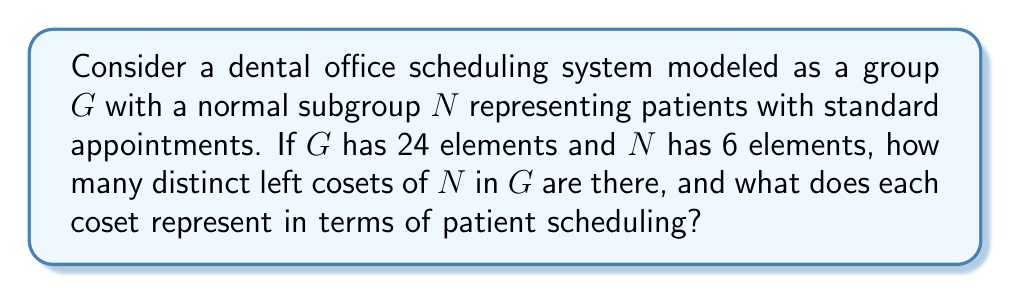Give your solution to this math problem. To solve this problem, we'll follow these steps:

1) Recall the Lagrange's Theorem: For a finite group $G$ and a subgroup $H$ of $G$, the order of $H$ divides the order of $G$. The number of left cosets of $H$ in $G$ is equal to the index of $H$ in $G$, denoted as $[G:H]$, which is calculated as:

   $$[G:H] = \frac{|G|}{|H|}$$

   where $|G|$ is the order of $G$ and $|H|$ is the order of $H$.

2) In our case, $G$ is the entire scheduling system with 24 elements, and $N$ is the normal subgroup of standard appointments with 6 elements. So:

   $$[G:N] = \frac{|G|}{|N|} = \frac{24}{6} = 4$$

3) This means there are 4 distinct left cosets of $N$ in $G$.

4) Since $N$ is a normal subgroup, the left cosets are the same as the right cosets, and they form a partition of $G$.

5) In terms of patient scheduling, each coset can be interpreted as a category of appointments:
   - One coset (which is $N$ itself) represents standard appointments.
   - The other three cosets might represent different types of special appointments, such as emergency visits, follow-ups, or specialized procedures.

6) Each coset contains 6 elements (same as the order of $N$), which could represent different time slots or scheduling options within each category.

This grouping allows the dental receptionist to efficiently categorize and manage different types of appointments while maintaining the overall structure of the scheduling system.
Answer: There are 4 distinct left cosets of $N$ in $G$. Each coset represents a category of appointments in the dental office scheduling system, with one coset for standard appointments and three for different types of special appointments. 